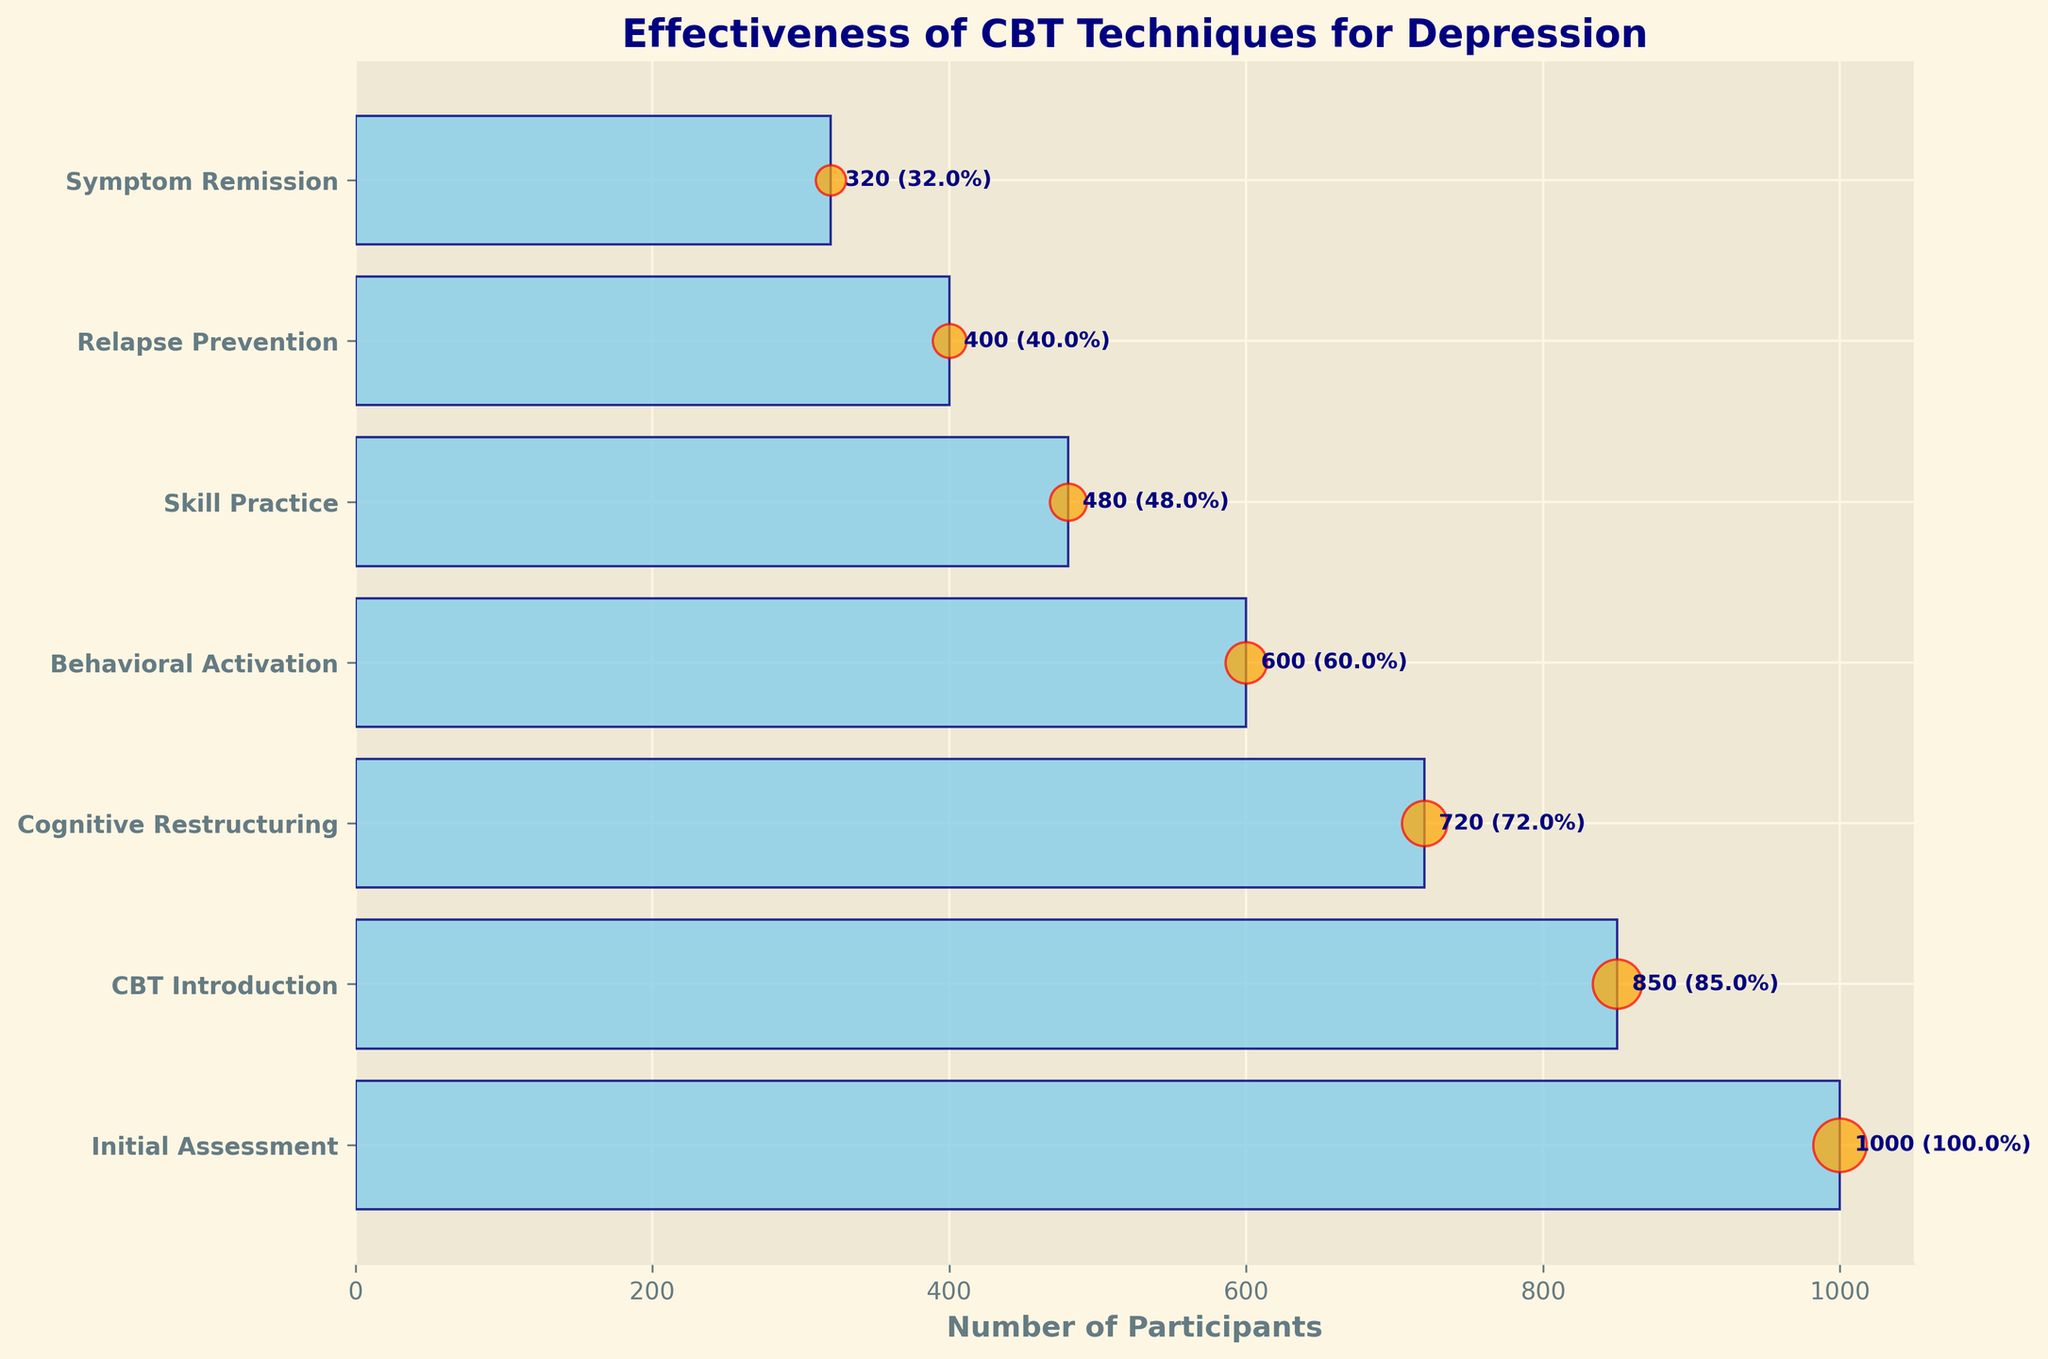what is the title of the chart? The title of the chart is displayed at the top of the figure, and it reads "Effectiveness of CBT Techniques for Depression."
Answer: Effectiveness of CBT Techniques for Depression What is the total number of participants who started with the Initial Assessment stage? The number of participants at each stage is indicated by the horizontal bars in the chart and explicitly labeled next to the bar representing the Initial Assessment stage.
Answer: 1000 What is the success rate at the Cognitive Restructuring stage? The success rate is labeled as a percentage next to the bar representing the Cognitive Restructuring stage.
Answer: 72% How many more participants were there in the Behavioral Activation stage compared to the Relapse Prevention stage? The number of participants in the Behavioral Activation stage is 600, and the number in the Relapse Prevention stage is 400. The difference is 600 - 400.
Answer: 200 How does the number of participants at the Behavioral Activation stage compare to those at the Skill Practice stage? The chart shows that the number of participants at the Behavioral Activation stage is 600, while at the Skill Practice stage, it is 480. Therefore, there are more participants at the Behavioral Activation stage.
Answer: Behavioral Activation What is the overall success rate from the Initial Assessment to Symptom Remission? The overall success rate is the ratio of participants who reached Symptom Remission to those initially assessed. This is calculated as (320/1000) * 100%.
Answer: 32% What stage has the largest drop in the number of participants compared to the previous stage? By comparing the number of participants visually between each successive stage, the largest drop is seen between Cognitive Restructuring (720) and Behavioral Activation (600), a difference of 120 participants.
Answer: Cognitive Restructuring to Behavioral Activation What percentage of participants remain after the Skill Practice stage? The number of participants at the Skill Practice stage is 480. Out of the initial 1000 participants, this represents (480/1000) * 100%.
Answer: 48% What is the difference in success rates between the CBT Introduction stage and the Symptom Remission stage? The success rate at the CBT Introduction stage is 85%, while at the Symptom Remission stage, it is 32%. The difference is 85% - 32%.
Answer: 53% How do the success rates change from Behavioral Activation to Relapse Prevention? The success rate at the Behavioral Activation stage is 60%, and at the Relapse Prevention stage, it drops to 40%.
Answer: Decreases by 20% 